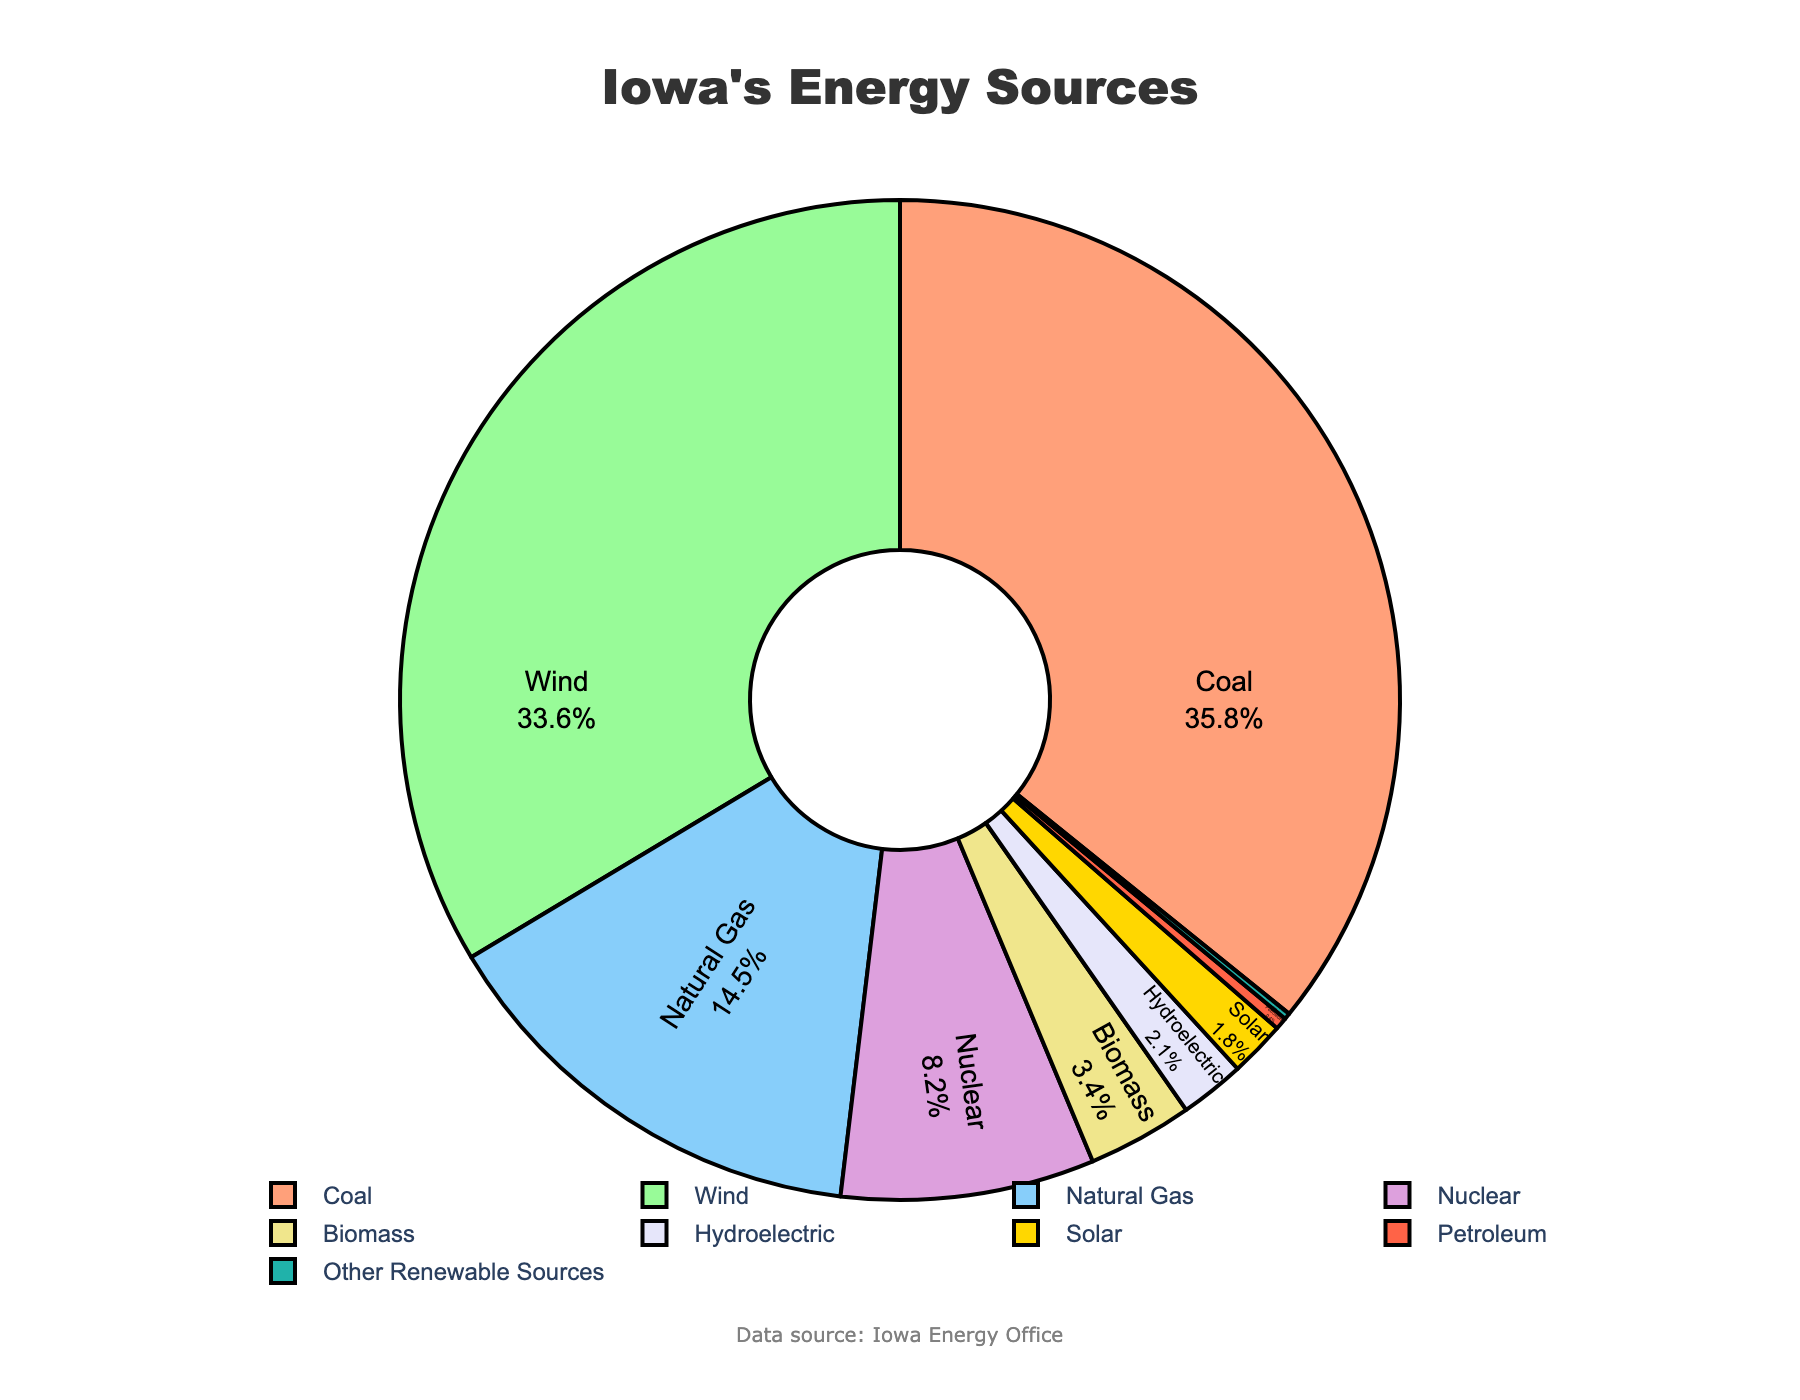What percentage of Iowa's energy comes from renewable sources excluding wind? First, identify all renewable energy sources besides wind: Biomass (3.4%), Hydroelectric (2.1%), Solar (1.8%), and Other Renewable Sources (0.2%). Sum them up to get 3.4 + 2.1 + 1.8 + 0.2 which equals 7.5%
Answer: 7.5% Which energy source contributes more, coal or wind? Compare the two percentages for coal and wind. Coal contributes 35.8% and wind contributes 33.6%. Coal contributes more than wind.
Answer: Coal Is the combined percentage of nuclear and natural gas energy sources greater than wind energy? Sum the percentages of nuclear and natural gas: 8.2% + 14.5% = 22.7%. Compare this sum to wind's 33.6%. The combined percentage of nuclear and natural gas is less than wind.
Answer: No What is the smallest energy source, and what percentage does it represent? Identify the smallest slice in the pie chart which is labeled as "Other Renewable Sources" at 0.2%.
Answer: Other Renewable Sources How much larger is the percentage of coal compared to solar energy? Subtract the percentage of solar energy (1.8%) from the percentage of coal (35.8%): 35.8% - 1.8% = 34%.
Answer: 34% According to the visualization, do wind and nuclear energy sources together represent more than 40% of Iowa's energy? Sum the percentages of wind and nuclear: 33.6% + 8.2% = 41.8%. This is more than 40%, so the answer is yes.
Answer: Yes Which energy source is represented by the light blue color? Identify the slice with the light blue color and read the associated label, which is "Natural Gas."
Answer: Natural Gas 